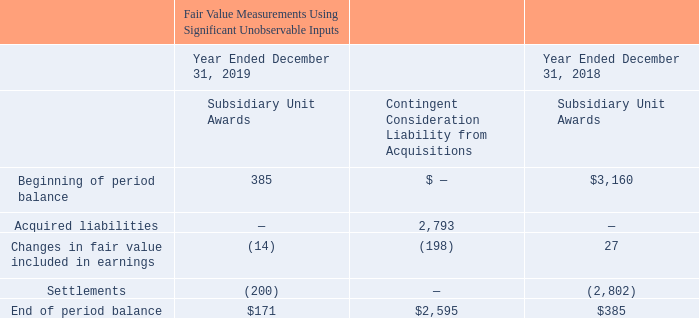The following table summarizes the change in fair value of the Level 3 liabilities with significant unobservable inputs (in thousands):
The money market accounts are included in our cash and cash equivalents in our consolidated balance sheets. Our money market assets are valued using quoted prices in active markets.
The liability for the subsidiary unit awards relates to agreements established with employees of our subsidiaries for cash awards contingent upon the subsidiary companies meeting certain financial milestones such as revenue, working capital, EBITDA and EBITDA margin. We account for these subsidiary awards using fair value and establish liabilities for the future payment for the repurchase of subsidiary units under the terms of the agreements based on estimating revenue, working capital, EBITDA and EBITDA margin of the subsidiary units over the periods of the awards through the anticipated repurchase dates. We estimated the fair value of each liability by using a Monte Carlo simulation model for determining each of the projected measures by using an expected distribution of potential outcomes. The fair value of each liability is calculated with thousands of projected outcomes, the results of which are averaged and then discounted to estimate the present value. At each reporting date until the respective payment dates, we will remeasure these liabilities, using the same valuation approach based on the applicable subsidiary's revenue and future collection of financed customer receivables, the unobservable inputs, and we will record any changes in the employee's compensation expense. Some of the awards are subject to the employees' continued employment and therefore, recorded on a straight-line basis over the remaining service period. During the year ended December 31, 2019, we settled $0.2 million of the liability related to the subsidiary unit awards. The remaining liability balances are included in either accounts payable, accrued expenses and other current liabilities or other liabilities in our consolidated balance sheets (see Note 13).
The contingent consideration liability consists of the potential earn-out payment related to our acquisition of 85% of the issued and outstanding capital stock of OpenEye on October 21, 2019. The earn-out payment is contingent on the satisfaction of certain calendar 2020 revenue targets and has a maximum potential payment of up to $11.0 million. We account for the contingent consideration using fair value and establish a liability for the future earn-out payment based on an estimation of revenue attributable to perpetual licenses and subscription licenses over the 2020 calendar year. We estimated the fair value of the liability by using a Monte Carlo simulation model for determining each of the projected measures by using an expected distribution of potential outcomes. The contingent consideration liability was valued with Level 3 unobservable inputs, including the revenue volatility and the discount rate. At October 21, 2019, the fair value of the liability was $2.8 million. At each reporting date until the payment date in 2021, we will remeasure the liability, using the same valuation approach. Changes in the fair value resulting from information that existed subsequent to the acquisition date are recorded in the consolidated statements of operations. During the year ended December 31, 2019, the contingent consideration liability decreased $0.2 million to $2.6 million as compared to the initial liability recorded at the acquisition date, primarily due to a change to OpenEye's 2020 projected revenue. The unobservable inputs used in the valuation as of December 31, 2019 included a revenue volatility of 45% and a discount rate of 3%. Selecting another revenue volatility or discount rate within an acceptable range would not result in a significant change to the fair value of the contingent consideration liability.
The contingent consideration liability is included in other liabilities in our consolidated balance sheet as of December 31, 2019 (see Note 13).
We monitor the availability of observable market data to assess the appropriate classification of financial instruments within the fair value hierarchy. Changes in economic conditions or model-based valuation techniques may require the transfer of financial instruments from one fair value level to another. In such instances, the transfer is reported at the beginning of the reporting period. There were no transfers between Levels 1, 2 or 3 during the years ended December 31, 2019, 2018 and 2017. We also monitor the value of the investments for other-than-temporary impairment on a quarterly basis. No other-than-temporary impairments occurred during the years ended December 31, 2019, 2018 and 2017.
What was the beginning of period balance of subsidiary unit awards in 2019?
Answer scale should be: thousand. 385. What was the Contingent Consideration Liability from Acquisitions accrued liabilities in 2019?
Answer scale should be: thousand. 2,793. Where did the company include their money market accounts in their consolidated balance sheets? Cash and cash equivalents. What was the change in Beginning and ending period balance for Subsidiary Unit Awards in 2018?
Answer scale should be: thousand. 385-3,160
Answer: -2775. How many years did the beginning of period balance exceed $2,000 thousand? 2018
Answer: 1. What was the percentage change in the end of period balance for Subsidiary Unit Awards between 2018 and 2019?
Answer scale should be: percent. (171-385)/385
Answer: -55.58. 